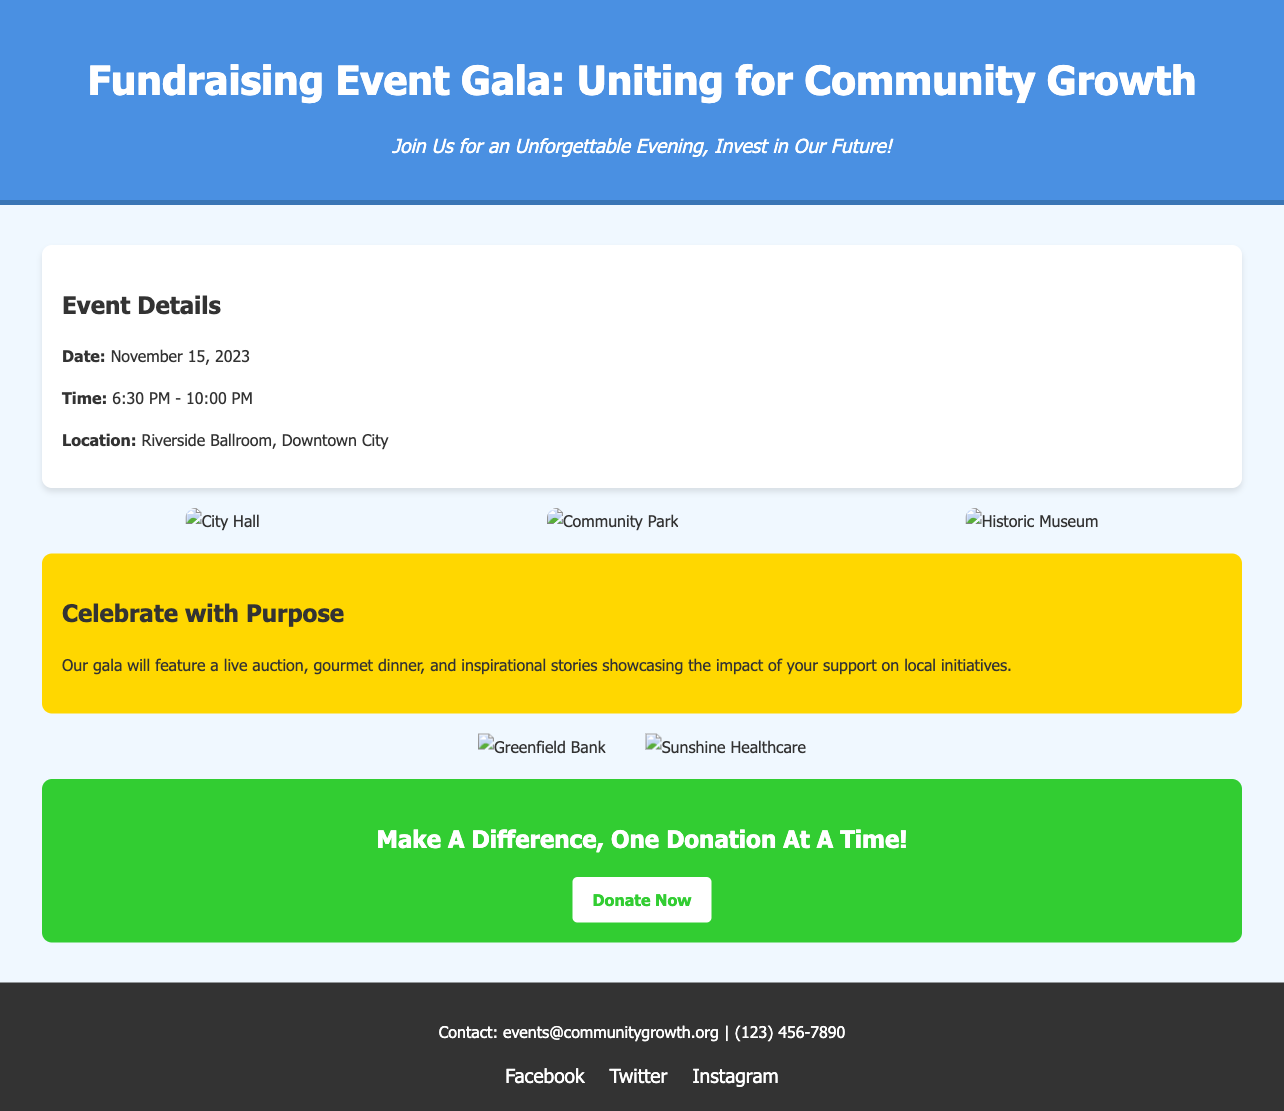What is the date of the event? The event is scheduled for November 15, 2023.
Answer: November 15, 2023 What time does the gala start? The gala starts at 6:30 PM.
Answer: 6:30 PM Where is the event located? The event will take place at Riverside Ballroom, Downtown City.
Answer: Riverside Ballroom, Downtown City What does the highlight section mention? It describes the features of the gala including a live auction, gourmet dinner, and inspirational stories.
Answer: Live auction, gourmet dinner, and inspirational stories Which two sponsors are featured? The sponsors listed are Greenfield Bank and Sunshine Healthcare.
Answer: Greenfield Bank and Sunshine Healthcare What is the main call to action? The call to action encourages people to donate, expressed as "Make A Difference, One Donation At A Time!"
Answer: Make A Difference, One Donation At A Time! What type of imagery is featured in the invitations? The invitations showcase vibrant imagery of local landmarks.
Answer: Local landmarks 